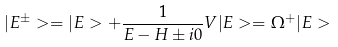Convert formula to latex. <formula><loc_0><loc_0><loc_500><loc_500>| E ^ { \pm } > = | E > + \frac { 1 } { E - H \pm i 0 } V | E > = \Omega ^ { + } | E ></formula> 